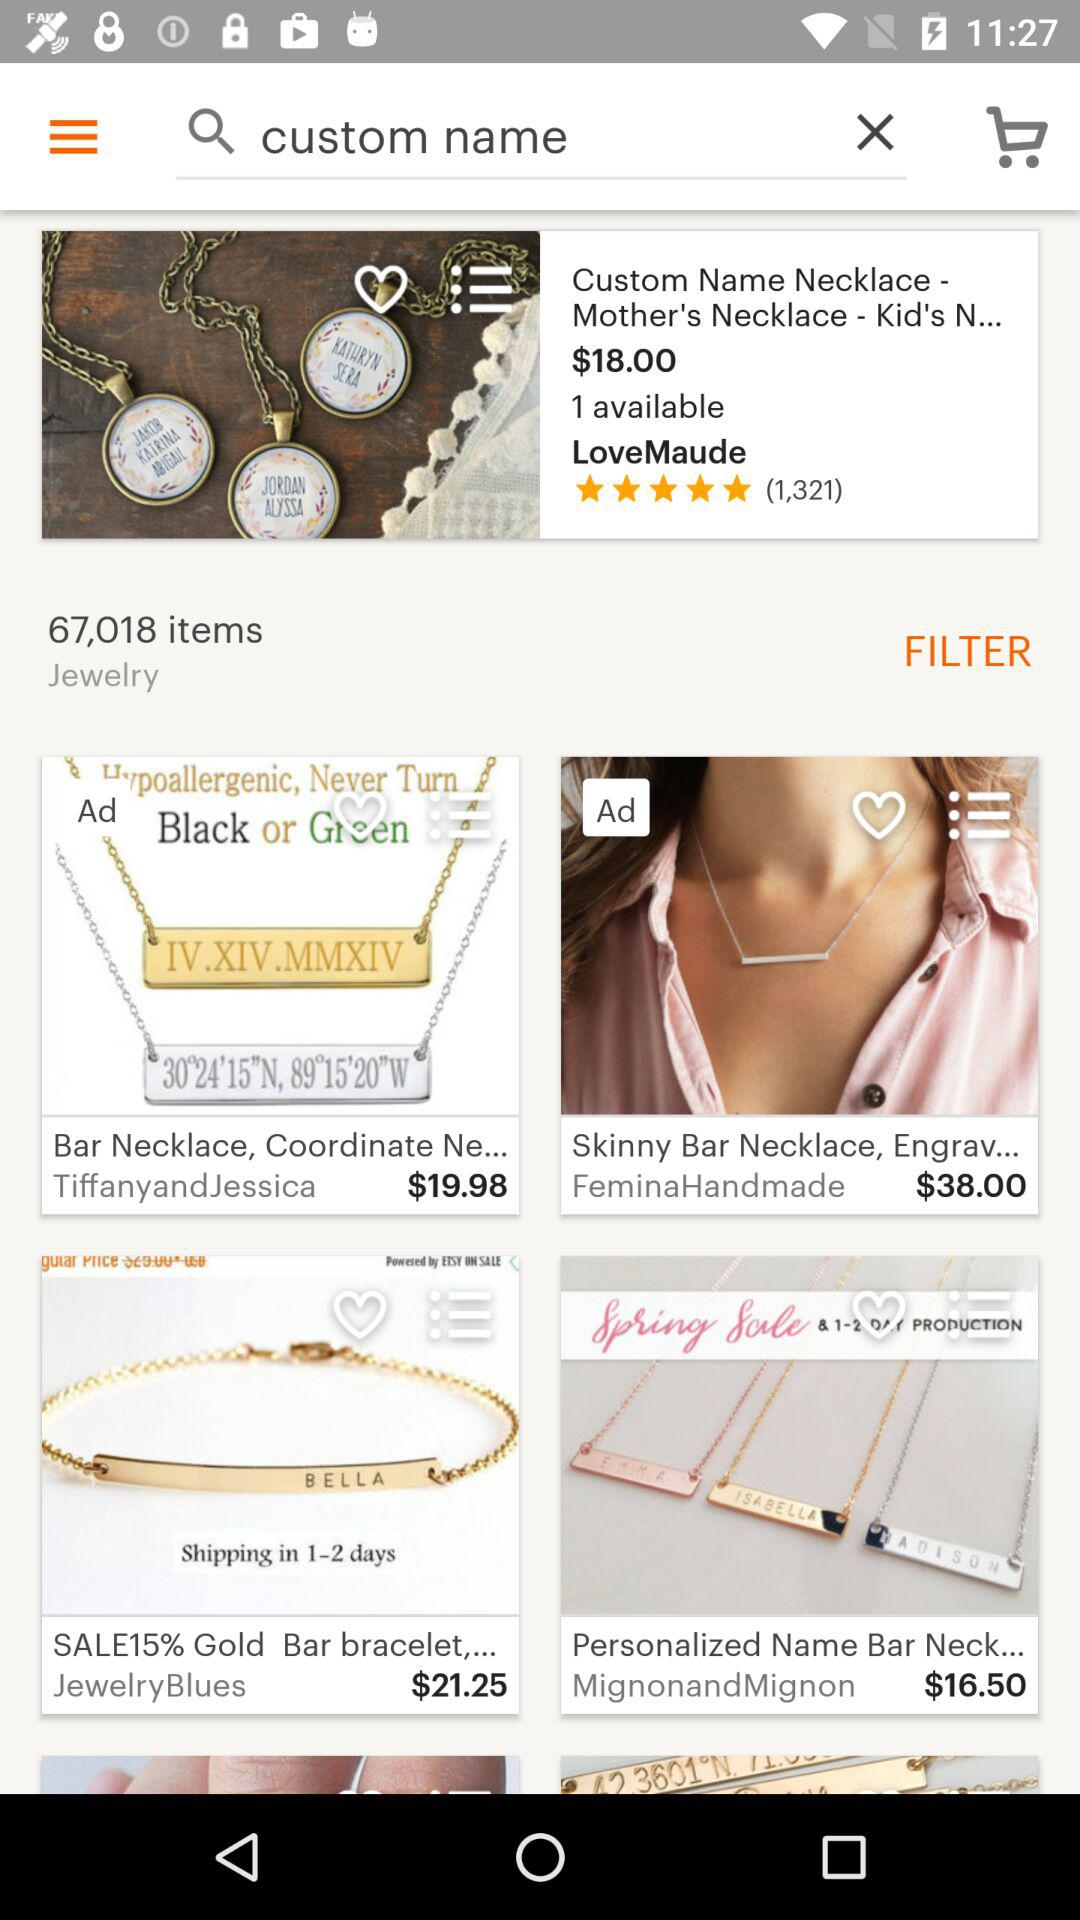How much is the most expensive item?
Answer the question using a single word or phrase. $38.00 